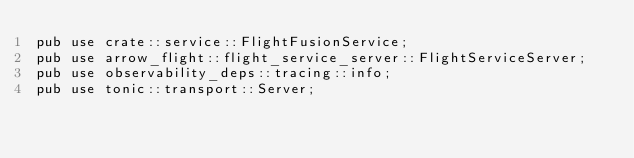Convert code to text. <code><loc_0><loc_0><loc_500><loc_500><_Rust_>pub use crate::service::FlightFusionService;
pub use arrow_flight::flight_service_server::FlightServiceServer;
pub use observability_deps::tracing::info;
pub use tonic::transport::Server;
</code> 